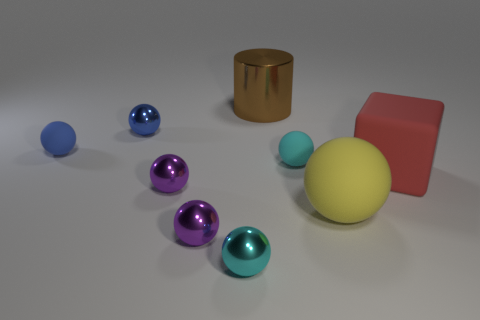Subtract 4 balls. How many balls are left? 3 Subtract all cyan spheres. How many spheres are left? 5 Subtract all purple spheres. How many spheres are left? 5 Subtract all red spheres. Subtract all yellow cubes. How many spheres are left? 7 Subtract all cylinders. How many objects are left? 8 Subtract 0 purple cylinders. How many objects are left? 9 Subtract all big yellow rubber things. Subtract all tiny blue shiny spheres. How many objects are left? 7 Add 8 large red objects. How many large red objects are left? 9 Add 5 small cyan rubber balls. How many small cyan rubber balls exist? 6 